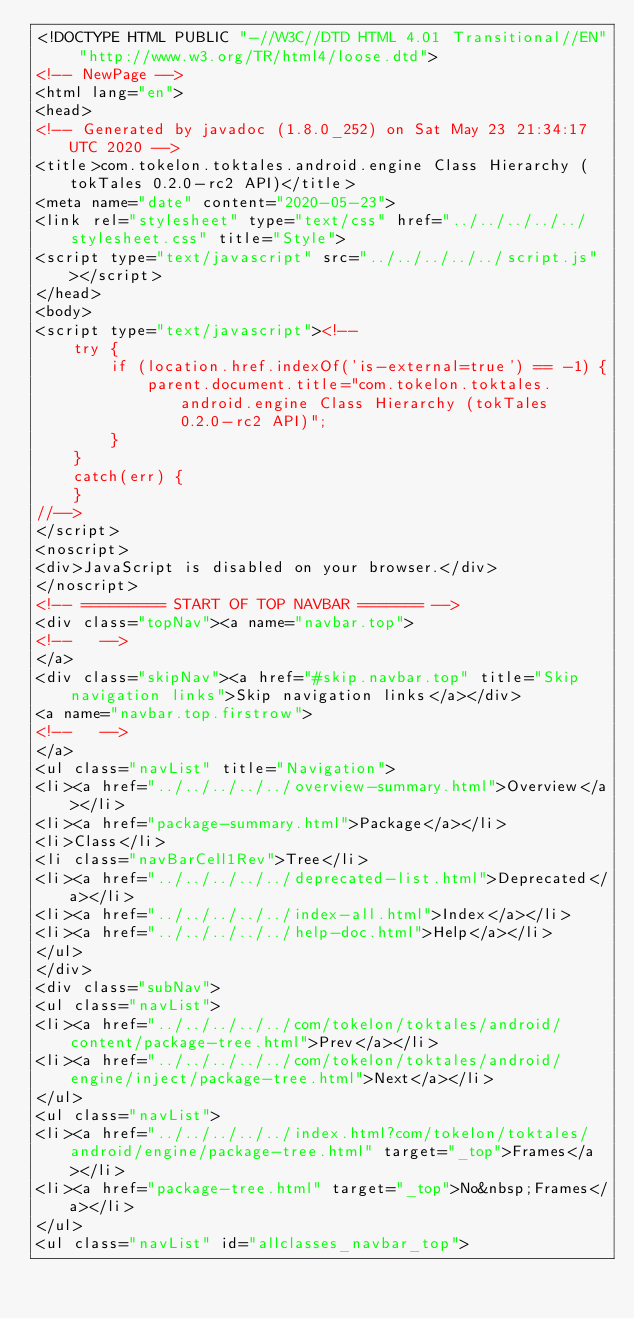<code> <loc_0><loc_0><loc_500><loc_500><_HTML_><!DOCTYPE HTML PUBLIC "-//W3C//DTD HTML 4.01 Transitional//EN" "http://www.w3.org/TR/html4/loose.dtd">
<!-- NewPage -->
<html lang="en">
<head>
<!-- Generated by javadoc (1.8.0_252) on Sat May 23 21:34:17 UTC 2020 -->
<title>com.tokelon.toktales.android.engine Class Hierarchy (tokTales 0.2.0-rc2 API)</title>
<meta name="date" content="2020-05-23">
<link rel="stylesheet" type="text/css" href="../../../../../stylesheet.css" title="Style">
<script type="text/javascript" src="../../../../../script.js"></script>
</head>
<body>
<script type="text/javascript"><!--
    try {
        if (location.href.indexOf('is-external=true') == -1) {
            parent.document.title="com.tokelon.toktales.android.engine Class Hierarchy (tokTales 0.2.0-rc2 API)";
        }
    }
    catch(err) {
    }
//-->
</script>
<noscript>
<div>JavaScript is disabled on your browser.</div>
</noscript>
<!-- ========= START OF TOP NAVBAR ======= -->
<div class="topNav"><a name="navbar.top">
<!--   -->
</a>
<div class="skipNav"><a href="#skip.navbar.top" title="Skip navigation links">Skip navigation links</a></div>
<a name="navbar.top.firstrow">
<!--   -->
</a>
<ul class="navList" title="Navigation">
<li><a href="../../../../../overview-summary.html">Overview</a></li>
<li><a href="package-summary.html">Package</a></li>
<li>Class</li>
<li class="navBarCell1Rev">Tree</li>
<li><a href="../../../../../deprecated-list.html">Deprecated</a></li>
<li><a href="../../../../../index-all.html">Index</a></li>
<li><a href="../../../../../help-doc.html">Help</a></li>
</ul>
</div>
<div class="subNav">
<ul class="navList">
<li><a href="../../../../../com/tokelon/toktales/android/content/package-tree.html">Prev</a></li>
<li><a href="../../../../../com/tokelon/toktales/android/engine/inject/package-tree.html">Next</a></li>
</ul>
<ul class="navList">
<li><a href="../../../../../index.html?com/tokelon/toktales/android/engine/package-tree.html" target="_top">Frames</a></li>
<li><a href="package-tree.html" target="_top">No&nbsp;Frames</a></li>
</ul>
<ul class="navList" id="allclasses_navbar_top"></code> 